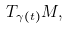<formula> <loc_0><loc_0><loc_500><loc_500>T _ { \gamma ( t ) } M ,</formula> 